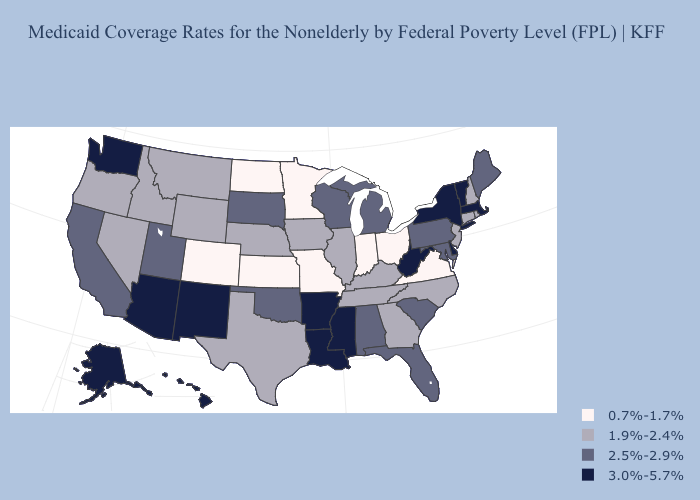Among the states that border Illinois , does Indiana have the highest value?
Concise answer only. No. Which states hav the highest value in the South?
Quick response, please. Arkansas, Delaware, Louisiana, Mississippi, West Virginia. Name the states that have a value in the range 2.5%-2.9%?
Short answer required. Alabama, California, Florida, Maine, Maryland, Michigan, Oklahoma, Pennsylvania, South Carolina, South Dakota, Utah, Wisconsin. What is the highest value in states that border Maine?
Write a very short answer. 1.9%-2.4%. Is the legend a continuous bar?
Give a very brief answer. No. What is the lowest value in states that border Alabama?
Keep it brief. 1.9%-2.4%. Which states have the highest value in the USA?
Give a very brief answer. Alaska, Arizona, Arkansas, Delaware, Hawaii, Louisiana, Massachusetts, Mississippi, New Mexico, New York, Vermont, Washington, West Virginia. Which states have the highest value in the USA?
Quick response, please. Alaska, Arizona, Arkansas, Delaware, Hawaii, Louisiana, Massachusetts, Mississippi, New Mexico, New York, Vermont, Washington, West Virginia. What is the value of Pennsylvania?
Keep it brief. 2.5%-2.9%. Name the states that have a value in the range 2.5%-2.9%?
Short answer required. Alabama, California, Florida, Maine, Maryland, Michigan, Oklahoma, Pennsylvania, South Carolina, South Dakota, Utah, Wisconsin. Among the states that border Rhode Island , does Massachusetts have the lowest value?
Be succinct. No. What is the value of Virginia?
Quick response, please. 0.7%-1.7%. Does the map have missing data?
Concise answer only. No. What is the highest value in the MidWest ?
Answer briefly. 2.5%-2.9%. 